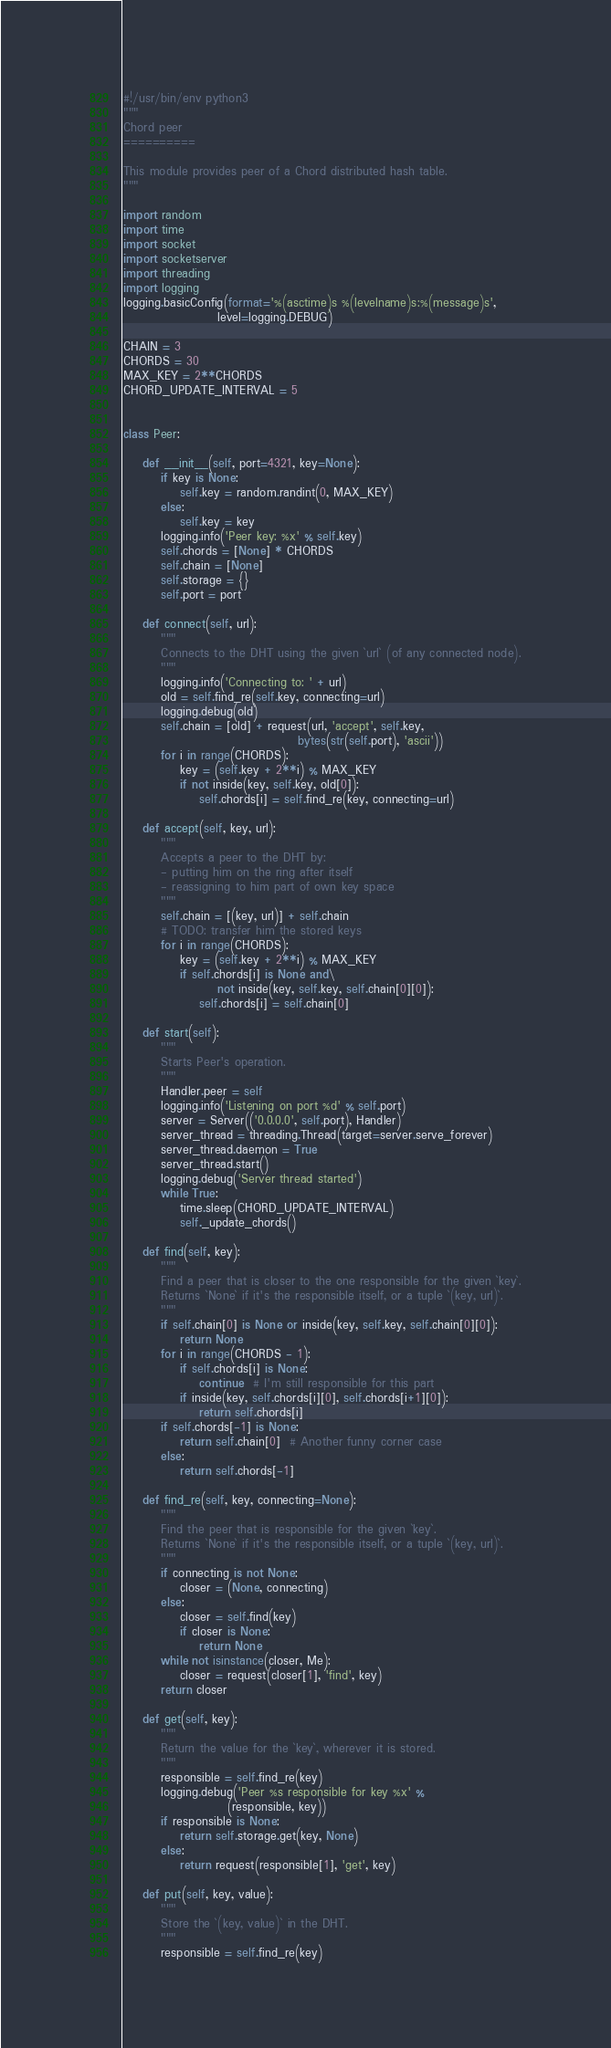<code> <loc_0><loc_0><loc_500><loc_500><_Python_>#!/usr/bin/env python3
"""
Chord peer
==========

This module provides peer of a Chord distributed hash table.
"""

import random
import time
import socket
import socketserver
import threading
import logging
logging.basicConfig(format='%(asctime)s %(levelname)s:%(message)s',
                    level=logging.DEBUG)

CHAIN = 3
CHORDS = 30
MAX_KEY = 2**CHORDS
CHORD_UPDATE_INTERVAL = 5


class Peer:

    def __init__(self, port=4321, key=None):
        if key is None:
            self.key = random.randint(0, MAX_KEY)
        else:
            self.key = key
        logging.info('Peer key: %x' % self.key)
        self.chords = [None] * CHORDS
        self.chain = [None]
        self.storage = {}
        self.port = port

    def connect(self, url):
        """
        Connects to the DHT using the given `url` (of any connected node).
        """
        logging.info('Connecting to: ' + url)
        old = self.find_re(self.key, connecting=url)
        logging.debug(old)
        self.chain = [old] + request(url, 'accept', self.key,
                                     bytes(str(self.port), 'ascii'))
        for i in range(CHORDS):
            key = (self.key + 2**i) % MAX_KEY
            if not inside(key, self.key, old[0]):
                self.chords[i] = self.find_re(key, connecting=url)

    def accept(self, key, url):
        """
        Accepts a peer to the DHT by:
        - putting him on the ring after itself
        - reassigning to him part of own key space
        """
        self.chain = [(key, url)] + self.chain
        # TODO: transfer him the stored keys
        for i in range(CHORDS):
            key = (self.key + 2**i) % MAX_KEY
            if self.chords[i] is None and\
                    not inside(key, self.key, self.chain[0][0]):
                self.chords[i] = self.chain[0]

    def start(self):
        """
        Starts Peer's operation.
        """
        Handler.peer = self
        logging.info('Listening on port %d' % self.port)
        server = Server(('0.0.0.0', self.port), Handler)
        server_thread = threading.Thread(target=server.serve_forever)
        server_thread.daemon = True
        server_thread.start()
        logging.debug('Server thread started')
        while True:
            time.sleep(CHORD_UPDATE_INTERVAL)
            self._update_chords()

    def find(self, key):
        """
        Find a peer that is closer to the one responsible for the given `key`.
        Returns `None` if it's the responsible itself, or a tuple `(key, url)`.
        """
        if self.chain[0] is None or inside(key, self.key, self.chain[0][0]):
            return None
        for i in range(CHORDS - 1):
            if self.chords[i] is None:
                continue  # I'm still responsible for this part
            if inside(key, self.chords[i][0], self.chords[i+1][0]):
                return self.chords[i]
        if self.chords[-1] is None:
            return self.chain[0]  # Another funny corner case
        else:
            return self.chords[-1]

    def find_re(self, key, connecting=None):
        """
        Find the peer that is responsible for the given `key`.
        Returns `None` if it's the responsible itself, or a tuple `(key, url)`.
        """
        if connecting is not None:
            closer = (None, connecting)
        else:
            closer = self.find(key)
            if closer is None:
                return None
        while not isinstance(closer, Me):
            closer = request(closer[1], 'find', key)
        return closer

    def get(self, key):
        """
        Return the value for the `key`, wherever it is stored.
        """
        responsible = self.find_re(key)
        logging.debug('Peer %s responsible for key %x' %
                      (responsible, key))
        if responsible is None:
            return self.storage.get(key, None)
        else:
            return request(responsible[1], 'get', key)

    def put(self, key, value):
        """
        Store the `(key, value)` in the DHT.
        """
        responsible = self.find_re(key)</code> 